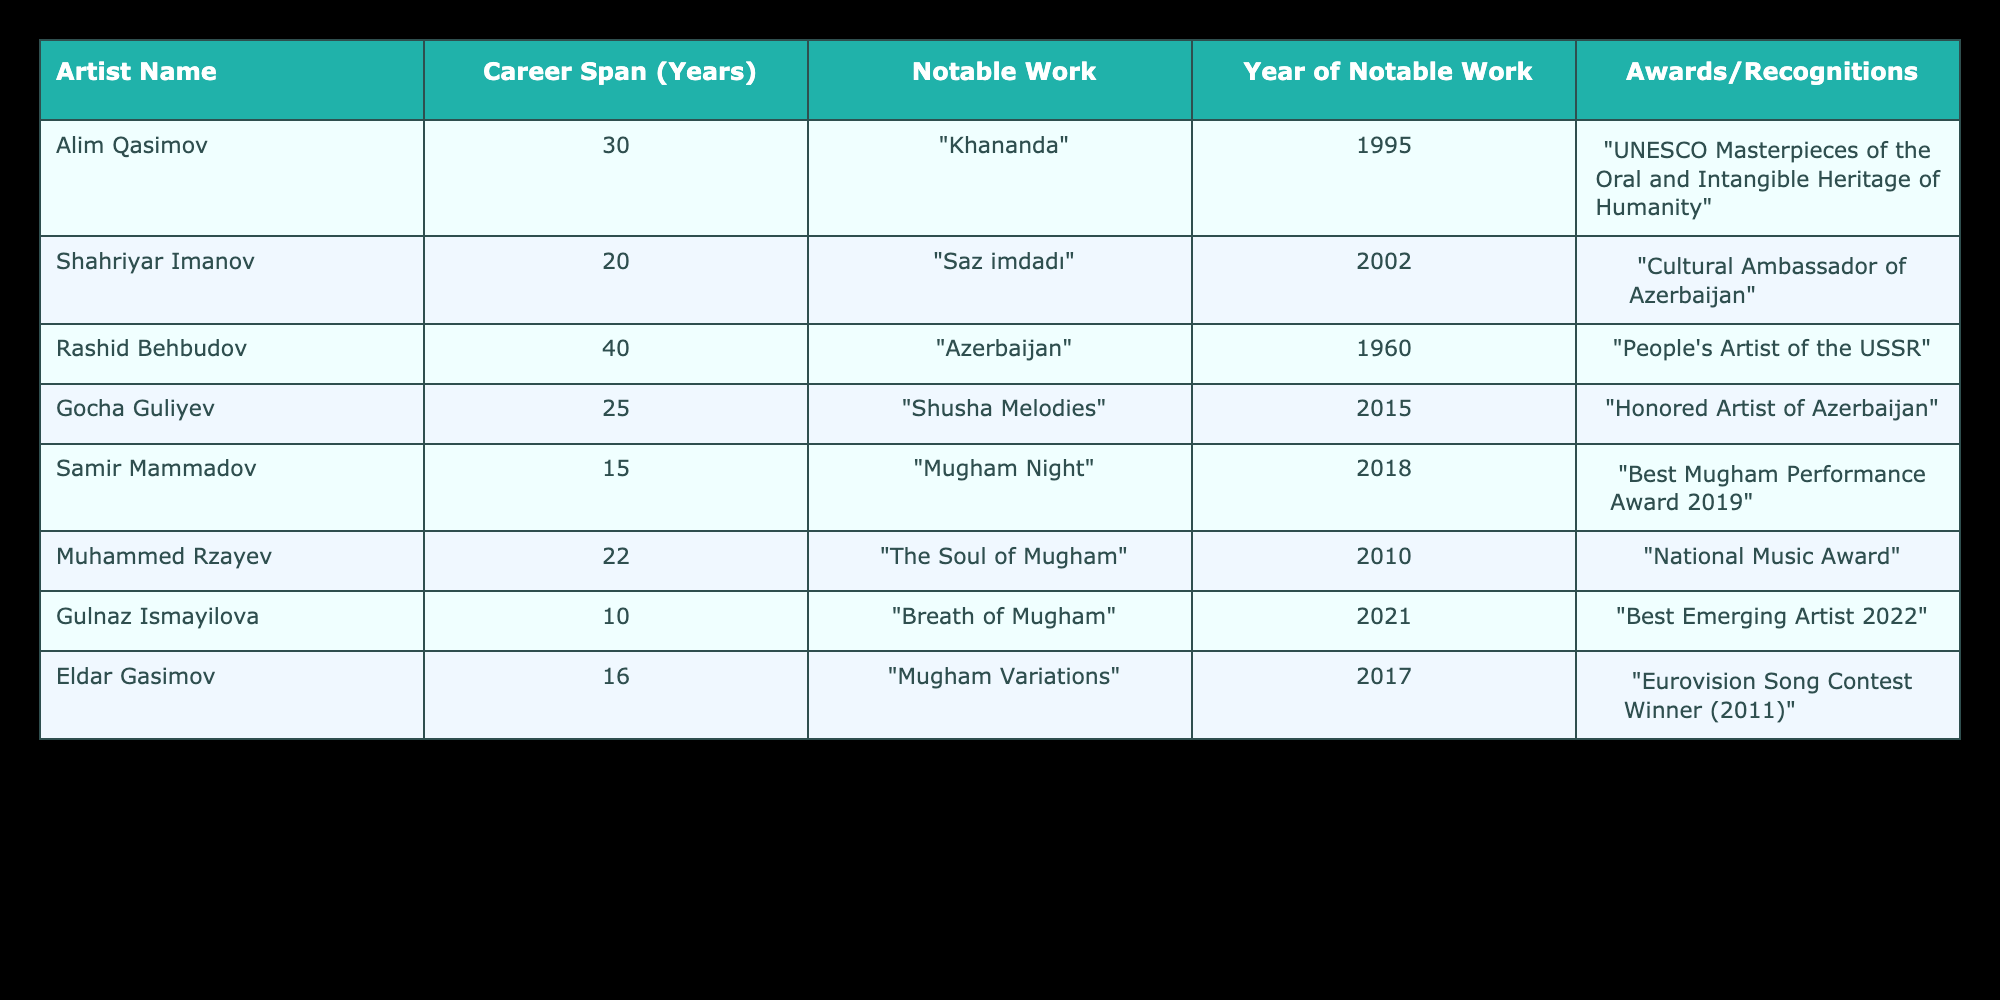What is the career span of Rashid Behbudov? According to the table, Rashid Behbudov has a career span of 40 years, which is directly mentioned in the "Career Span (Years)" column.
Answer: 40 years Which artist received the "Cultural Ambassador of Azerbaijan" recognition? The table indicates that Shahriyar Imanov received the "Cultural Ambassador of Azerbaijan" recognition in the "Awards/Recognitions" column.
Answer: Shahriyar Imanov What is the average career span of the artists listed in the table? To find the average career span, we sum the years of career spans: 30 + 20 + 40 + 25 + 15 + 22 + 10 + 16 = 168. Dividing this total by the number of artists (8), we calculate 168/8 = 21.
Answer: 21 years Did any artist receive an award before the year 2000? By examining the "Year of Notable Work" column, we see that Rashid Behbudov's notable work, "Azerbaijan," is listed for the year 1960, which is before 2000, confirming the fact.
Answer: Yes Which artist has the shortest career span? By reviewing the "Career Span (Years)" column, we see that Gulnaz Ismayilova has the shortest career span at 10 years compared to the other artists listed.
Answer: Gulnaz Ismayilova 